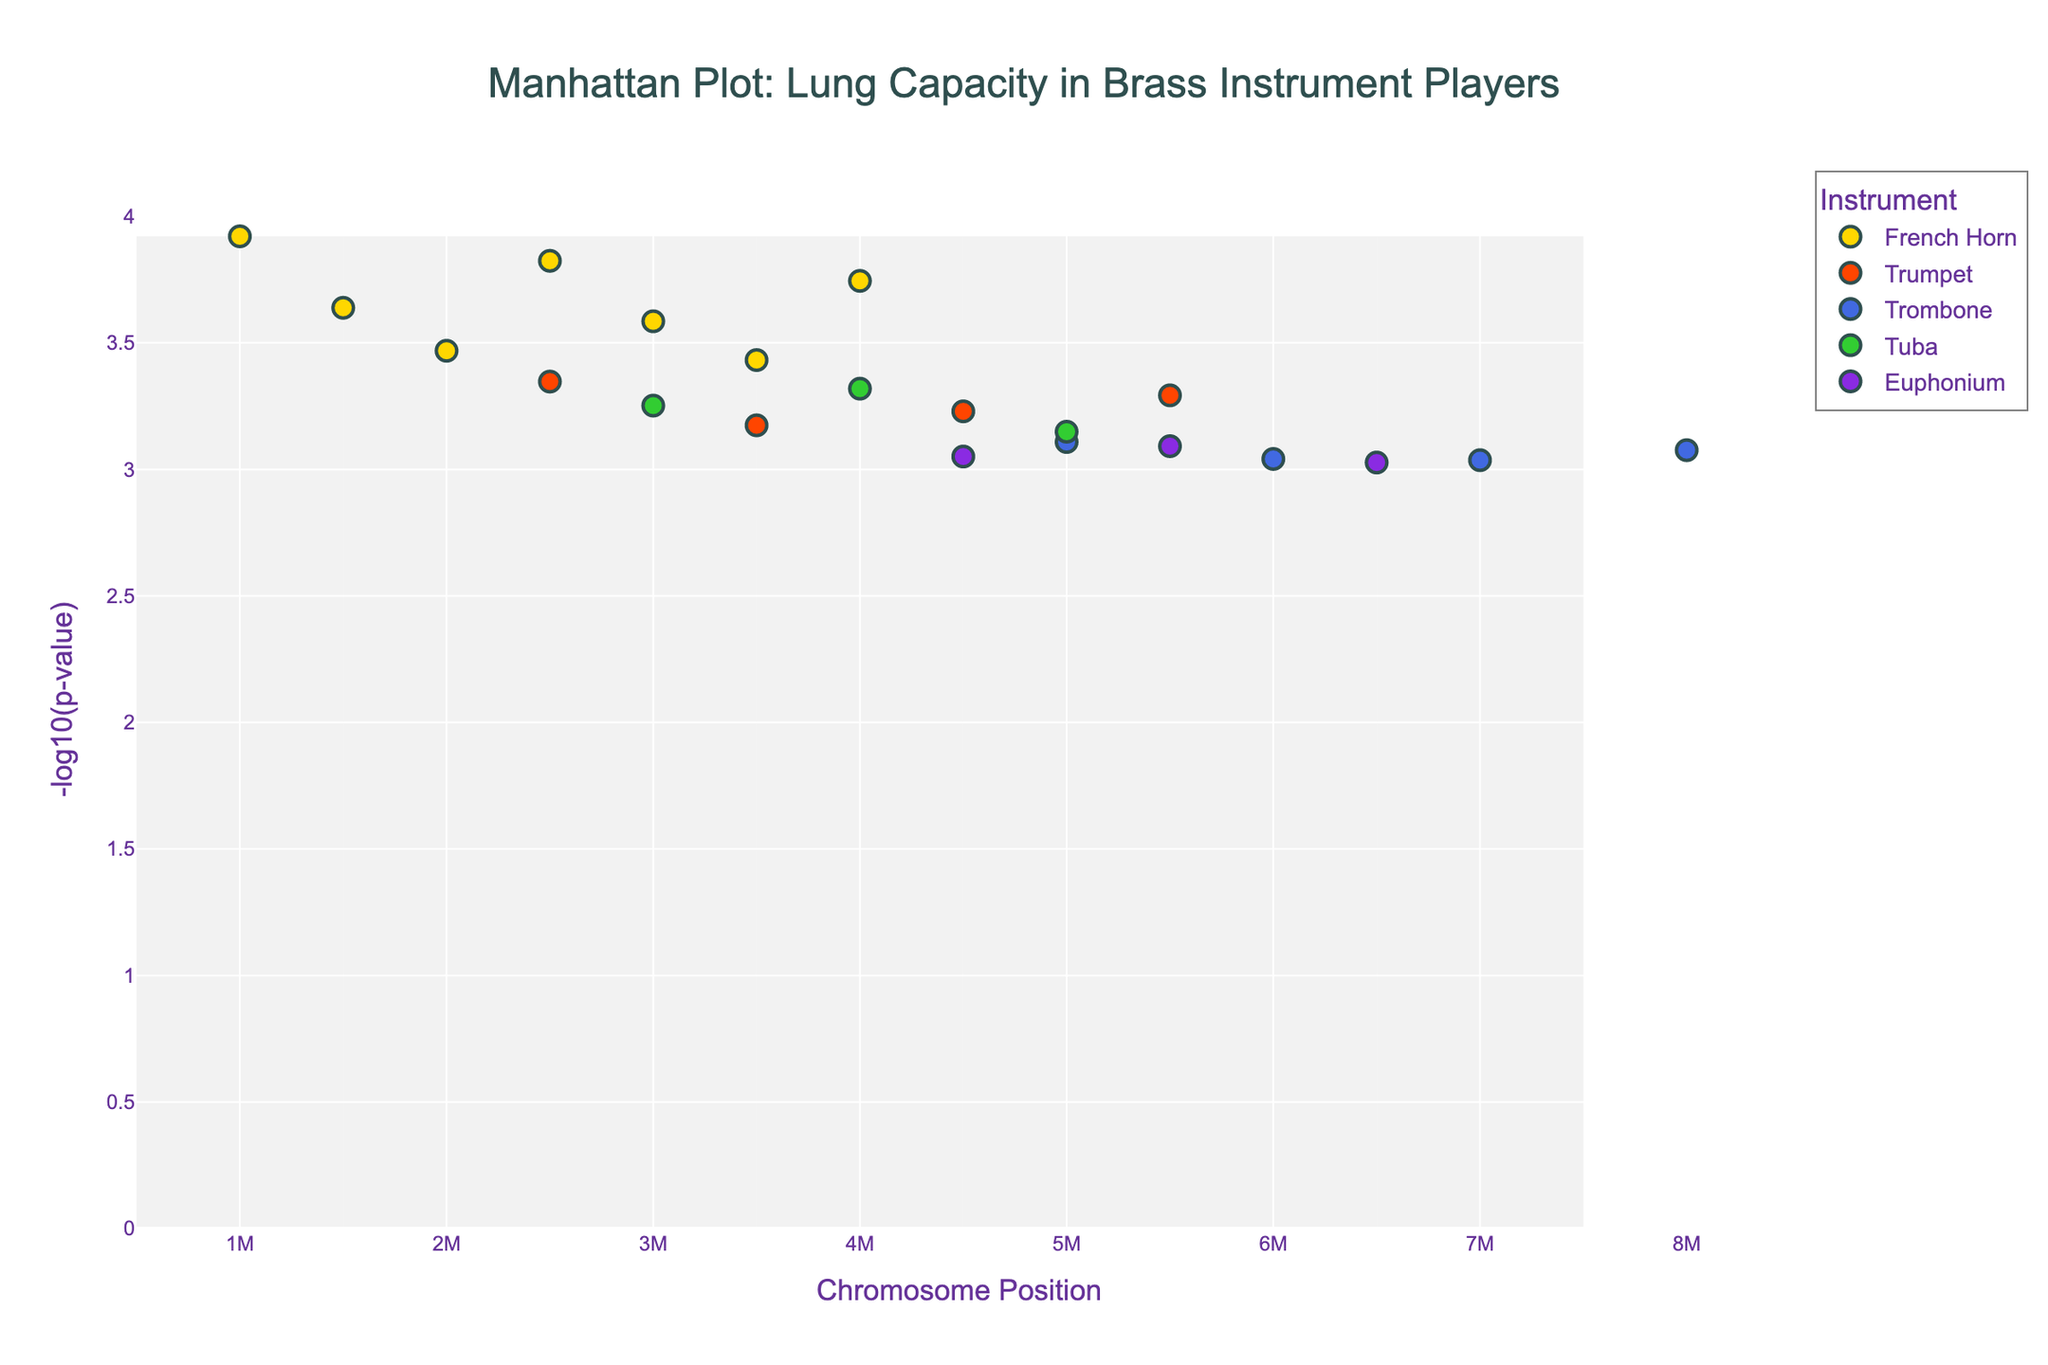What is the title of the plot? The title of the plot is typically found at the top. Here, it reads "Manhattan Plot: Lung Capacity in Brass Instrument Players".
Answer: Manhattan Plot: Lung Capacity in Brass Instrument Players Which instrument has the marker color gold? The color map in the legend shows that the gold color corresponds to the French Horn.
Answer: French Horn How many data points are plotted for the French Horn? By referring to the plotted points and matching them to the legend, we count the gold-colored markers, which represent French Horn. There are six data points.
Answer: 6 What is the x-axis title? The x-axis title is given below the x-axis and in this plot, it says "Chromosome Position".
Answer: Chromosome Position Which instrument has the highest -log10(p-value) on Chromosome 4? On Chromosome 4, look at the y-values of the different colors. The highest point belongs to the French Horn with a -log10(p-value) of approximately 3.82.
Answer: French Horn Between Trumpet and French Horn, which instrument generally shows lower p-values (higher -log10(p-values))? By comparing the -log10(p-values) for each data point of Trumpet (orange markers) and French Horn (gold markers), it is evident that French Horn generally has higher -log10(p-values).
Answer: French Horn What's the highest -log10(p-value) observed for French Horn across all chromosomes? Locate the highest gold marker on the y-axis. This marker has the value of 3.82 on Chromosome 4.
Answer: 3.82 Does any instrument show a significant presence on Chromosome 5 based on their p-values? On Chromosome 5, check the vertical positions of data points. French Horn and Trumpet have higher y-values, but no single instrument significantly dominates statistically.
Answer: No What’s the position with the highest p-value for Trombone players, given its plotted points? The highest p-value (lowest -log10(p-value)) for Trombone players is at position 7,800,000 on Chromosome 7. This corresponds to a -log10(p-value) of approximately 3.08.
Answer: 7,800,000 Compare the French Horn and Tuba for the number of data points with -log10(p-values) greater than 3. French Horn has 4 points (1,000,000; 1,500,000; 2,000,000; 2,500,000) with -log10(p-values) greater than 3, while Tuba has 3 points (3,000,000; 4,000,000; 5,000,000). Thus, French Horn has more such points.
Answer: French Horn 